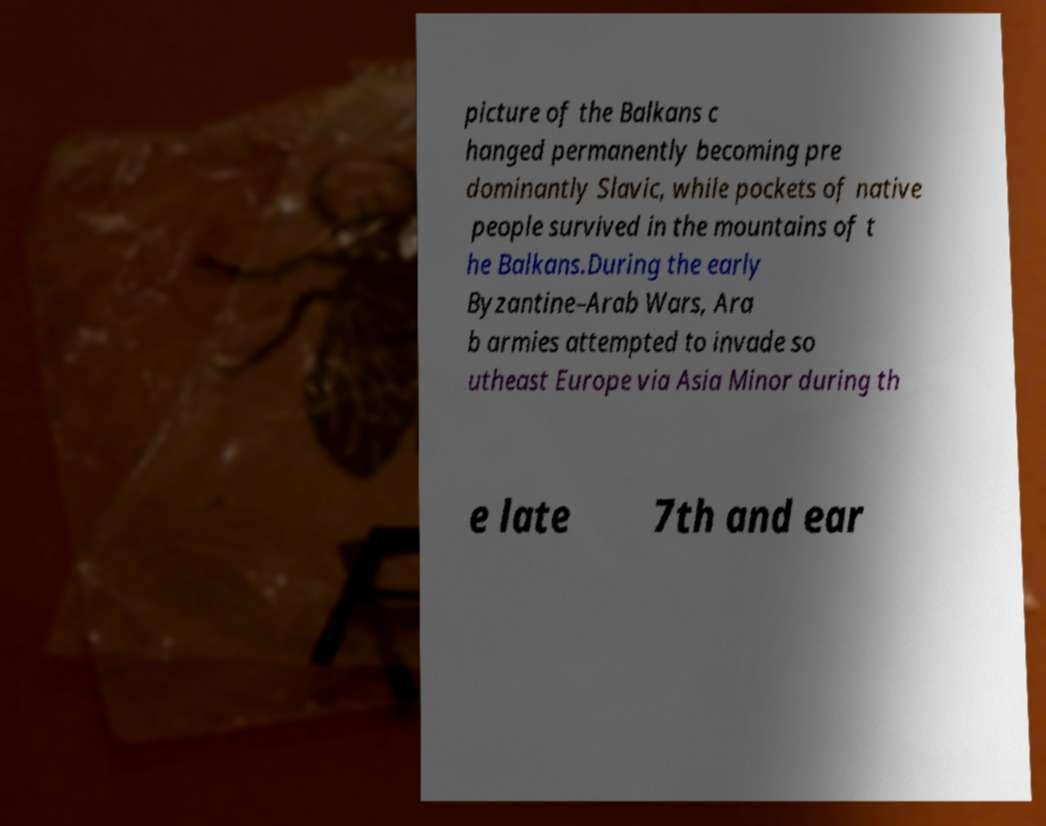Can you accurately transcribe the text from the provided image for me? picture of the Balkans c hanged permanently becoming pre dominantly Slavic, while pockets of native people survived in the mountains of t he Balkans.During the early Byzantine–Arab Wars, Ara b armies attempted to invade so utheast Europe via Asia Minor during th e late 7th and ear 